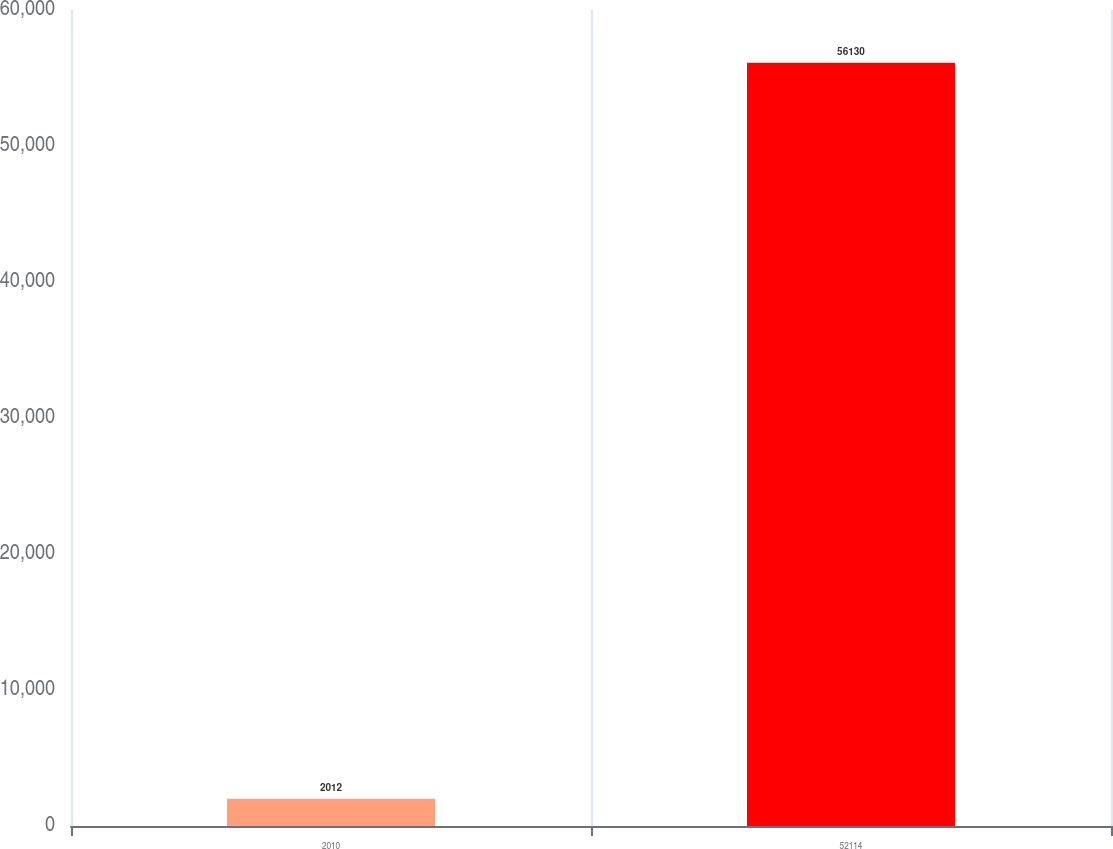Convert chart. <chart><loc_0><loc_0><loc_500><loc_500><bar_chart><fcel>2010<fcel>52114<nl><fcel>2012<fcel>56130<nl></chart> 